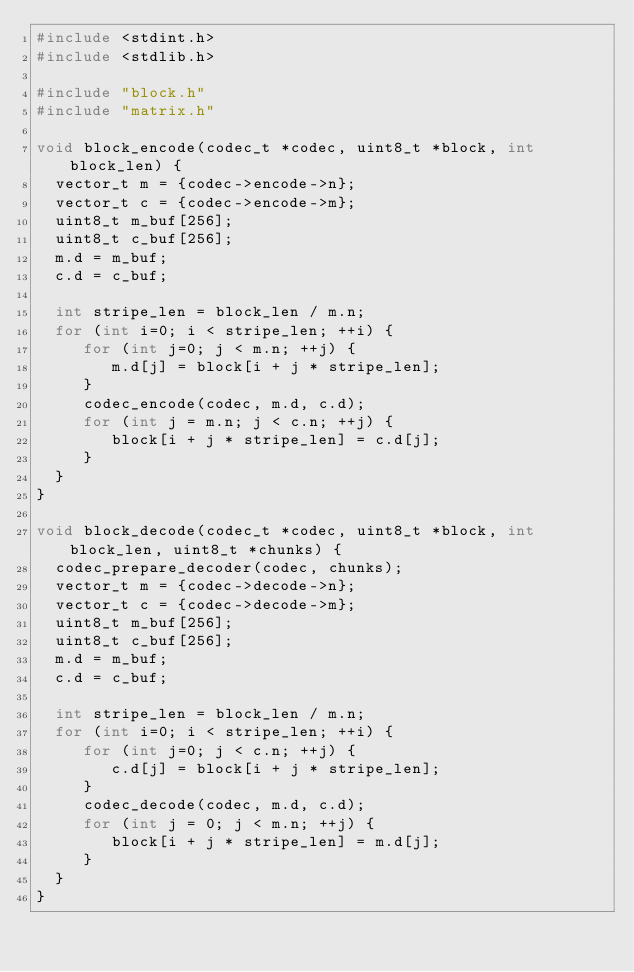<code> <loc_0><loc_0><loc_500><loc_500><_C_>#include <stdint.h>
#include <stdlib.h>

#include "block.h"
#include "matrix.h"

void block_encode(codec_t *codec, uint8_t *block, int block_len) {
  vector_t m = {codec->encode->n};
  vector_t c = {codec->encode->m};
  uint8_t m_buf[256];
  uint8_t c_buf[256];
  m.d = m_buf;
  c.d = c_buf;

  int stripe_len = block_len / m.n;
  for (int i=0; i < stripe_len; ++i) {
	 for (int j=0; j < m.n; ++j) {
		m.d[j] = block[i + j * stripe_len];
	 }
	 codec_encode(codec, m.d, c.d);
	 for (int j = m.n; j < c.n; ++j) {
		block[i + j * stripe_len] = c.d[j];
	 }
  }
}

void block_decode(codec_t *codec, uint8_t *block, int block_len, uint8_t *chunks) {
  codec_prepare_decoder(codec, chunks);
  vector_t m = {codec->decode->n};
  vector_t c = {codec->decode->m};
  uint8_t m_buf[256];
  uint8_t c_buf[256];
  m.d = m_buf;
  c.d = c_buf;

  int stripe_len = block_len / m.n;
  for (int i=0; i < stripe_len; ++i) {
	 for (int j=0; j < c.n; ++j) {
		c.d[j] = block[i + j * stripe_len];
	 }
	 codec_decode(codec, m.d, c.d);
	 for (int j = 0; j < m.n; ++j) {
		block[i + j * stripe_len] = m.d[j];
	 }
  }
}
</code> 